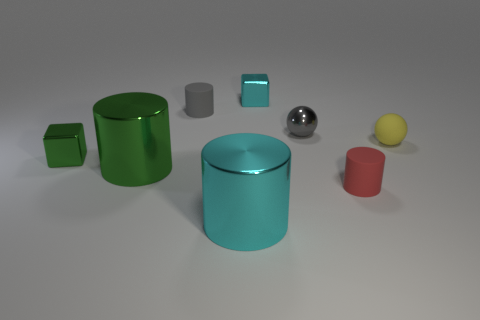Which of these objects appears to reflect the most light? The object that appears to reflect the most light is the silver sphere due to its shiny, metallic surface that acts like a mirror, reflecting the environment and light around it. 